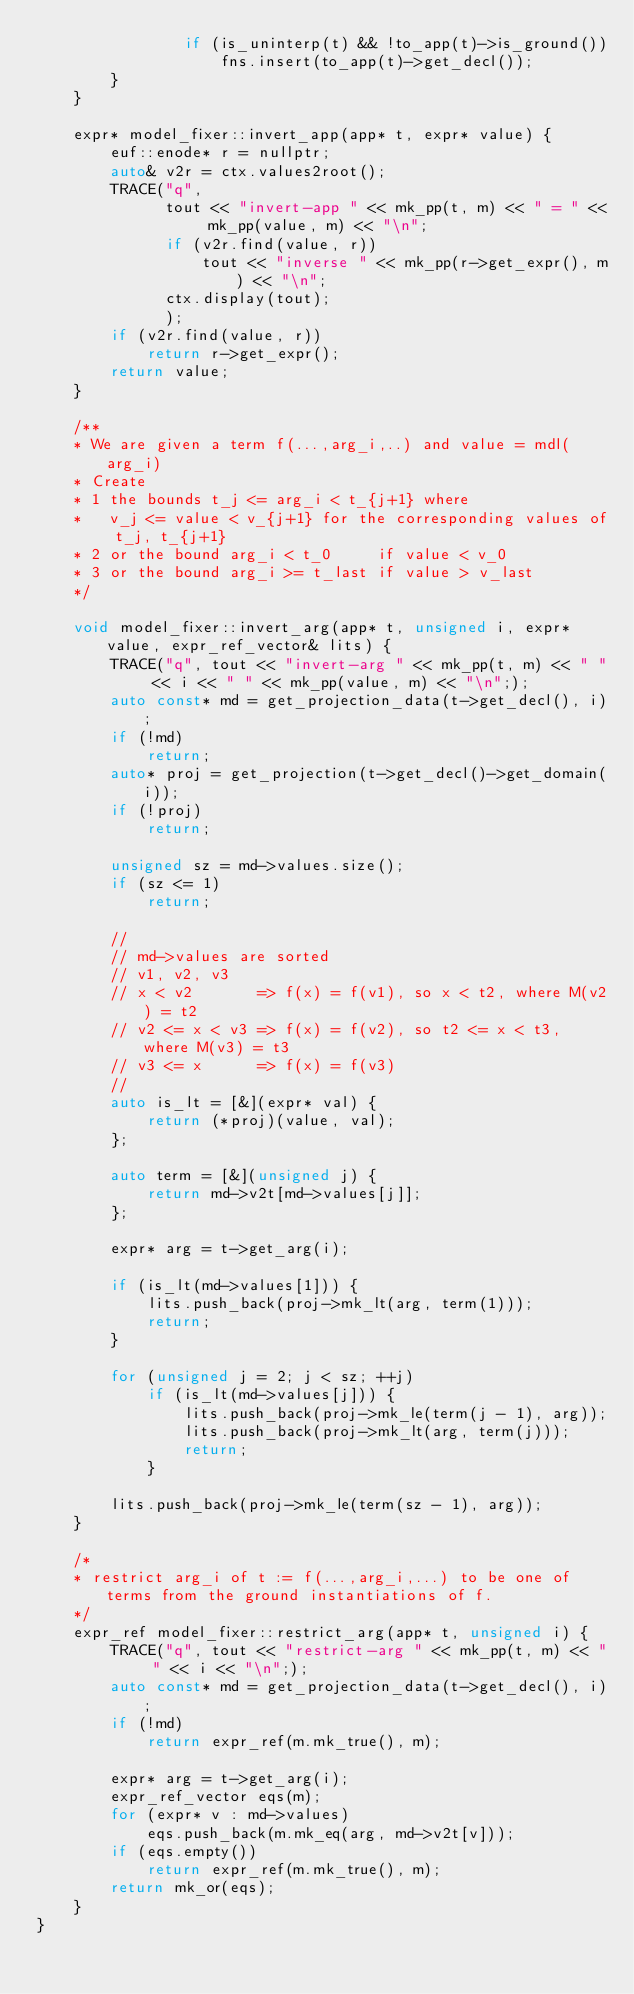<code> <loc_0><loc_0><loc_500><loc_500><_C++_>                if (is_uninterp(t) && !to_app(t)->is_ground())
                    fns.insert(to_app(t)->get_decl());
        }
    }

    expr* model_fixer::invert_app(app* t, expr* value) {
        euf::enode* r = nullptr;
        auto& v2r = ctx.values2root();
        TRACE("q",
              tout << "invert-app " << mk_pp(t, m) << " = " << mk_pp(value, m) << "\n";
              if (v2r.find(value, r)) 
                  tout << "inverse " << mk_pp(r->get_expr(), m) << "\n";
              ctx.display(tout);              
              );
        if (v2r.find(value, r)) 
            return r->get_expr();
        return value;
    }

    /**
    * We are given a term f(...,arg_i,..) and value = mdl(arg_i)
    * Create 
    * 1 the bounds t_j <= arg_i < t_{j+1} where 
    *   v_j <= value < v_{j+1} for the corresponding values of t_j, t_{j+1}
    * 2 or the bound arg_i < t_0     if value < v_0
    * 3 or the bound arg_i >= t_last if value > v_last
    */

    void model_fixer::invert_arg(app* t, unsigned i, expr* value, expr_ref_vector& lits) {
        TRACE("q", tout << "invert-arg " << mk_pp(t, m) << " " << i << " " << mk_pp(value, m) << "\n";);
        auto const* md = get_projection_data(t->get_decl(), i);
        if (!md)
            return;
        auto* proj = get_projection(t->get_decl()->get_domain(i));
        if (!proj)
            return;

        unsigned sz = md->values.size();
        if (sz <= 1)
            return;

        //
        // md->values are sorted
        // v1, v2, v3
        // x < v2       => f(x) = f(v1), so x < t2, where M(v2) = t2
        // v2 <= x < v3 => f(x) = f(v2), so t2 <= x < t3, where M(v3) = t3
        // v3 <= x      => f(x) = f(v3)
        // 
        auto is_lt = [&](expr* val) {
            return (*proj)(value, val);
        };

        auto term = [&](unsigned j) {
            return md->v2t[md->values[j]];
        };

        expr* arg = t->get_arg(i);

        if (is_lt(md->values[1])) {
            lits.push_back(proj->mk_lt(arg, term(1)));
            return;
        }

        for (unsigned j = 2; j < sz; ++j)
            if (is_lt(md->values[j])) {
                lits.push_back(proj->mk_le(term(j - 1), arg));
                lits.push_back(proj->mk_lt(arg, term(j)));
                return;
            }

        lits.push_back(proj->mk_le(term(sz - 1), arg));
    }

    /*
    * restrict arg_i of t := f(...,arg_i,...) to be one of terms from the ground instantiations of f.
    */
    expr_ref model_fixer::restrict_arg(app* t, unsigned i) {
        TRACE("q", tout << "restrict-arg " << mk_pp(t, m) << " " << i << "\n";);
        auto const* md = get_projection_data(t->get_decl(), i);
        if (!md)
            return expr_ref(m.mk_true(), m);

        expr* arg = t->get_arg(i);
        expr_ref_vector eqs(m);
        for (expr* v : md->values)
            eqs.push_back(m.mk_eq(arg, md->v2t[v]));
        if (eqs.empty())
            return expr_ref(m.mk_true(), m);
        return mk_or(eqs);
    }
}
</code> 